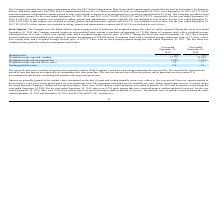According to Clearfield's financial document, What is the model used to determine the weighted average fair value of options granted? Black-Scholes option pricing model. The document states: "ost of sales. Stock Options: The Company uses the Black-Scholes option pricing model to determine the weighted average fair value of options granted. ..." Also, What is the weighted average exercise price during the fiscal year ended September 30, 2019? According to the financial document, $12.17. The relevant text states: "ing term, and a weighted average exercise price of $12.17. During the fiscal year ended September 30, 2018, the Company granted employees non-qualified stock..." Also, What is the vesting period (in years) in for the year ended September 30,2019? According to the financial document, 3.0. The relevant text states: "Weighted average expected life (in years) 3.0 3.7..." Also, can you calculate: What is the average vesting period for 2018 and 2019? To answer this question, I need to perform calculations using the financial data. The calculation is: (3.0+3.0)/2, which equals 3. This is based on the information: "Weighted average expected life (in years) 3.0 3.7..." Also, can you calculate: What is the percentage change in the compensation expense from 2018 to 2019? To answer this question, I need to perform calculations using the financial data. The calculation is: (1,729,025-2,003,207)/2,003,207, which equals -13.69 (percentage). This is based on the information: "ears ended September 30, 2019, 2018, and 2017 of $1,729,025, $2,003,207, and $2,319,975, respectively. For the year ended September 30, 2019, $1,638,829 of thi eptember 30, 2019, 2018, and 2017 of $1,..." The key data points involved are: 1,729,025, 2,003,207. Also, can you calculate: What is the change in the percentage of weighted average expected volatility from 2018 to 2019? Based on the calculation: 37.77-43.68, the result is -5.91 (percentage). This is based on the information: "Weighted average expected volatility 37.77% 43.68% Weighted average expected volatility 37.77% 43.68%..." The key data points involved are: 37.77, 43.68. 